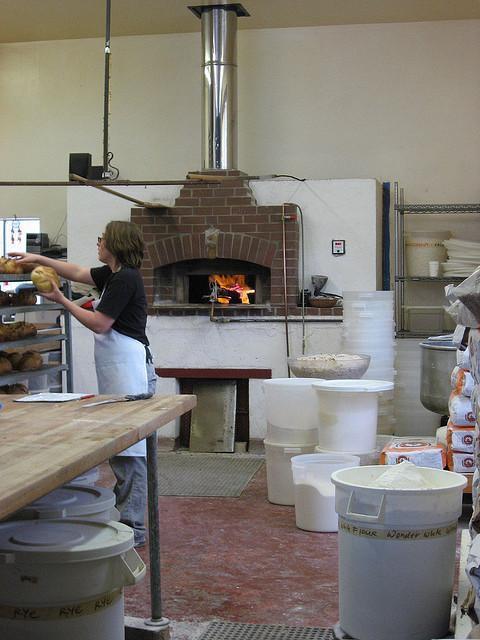How many people are in this room?
Give a very brief answer. 1. 